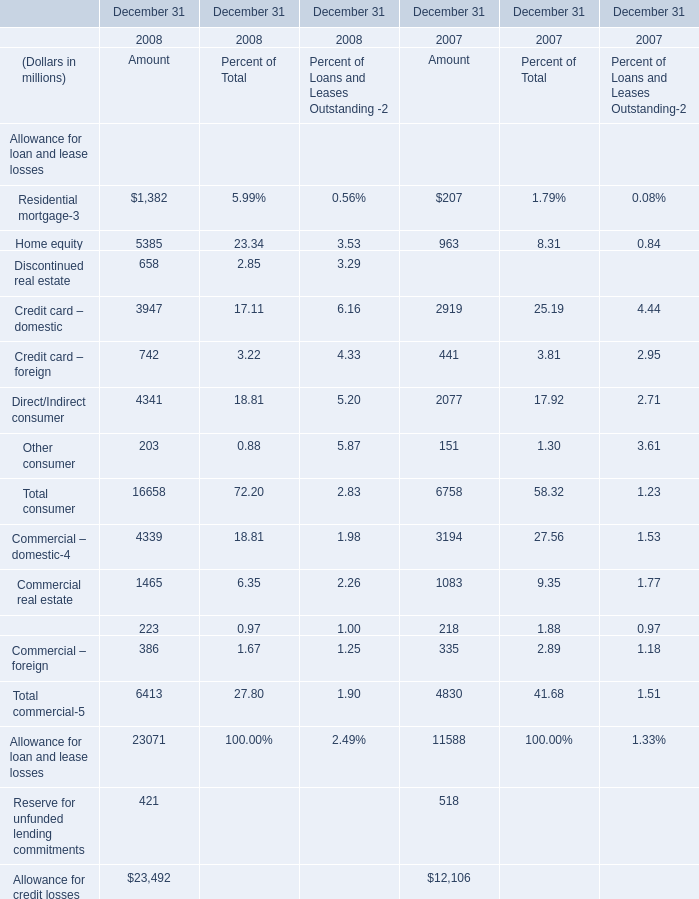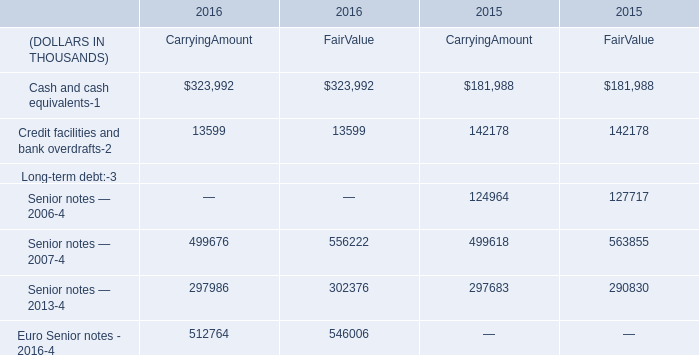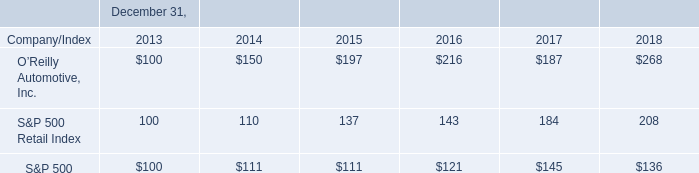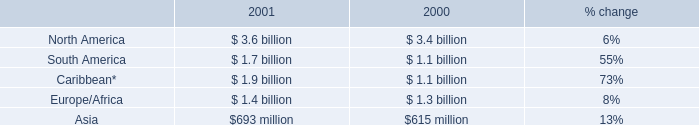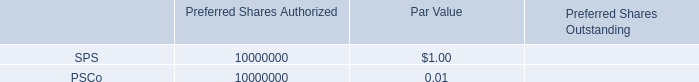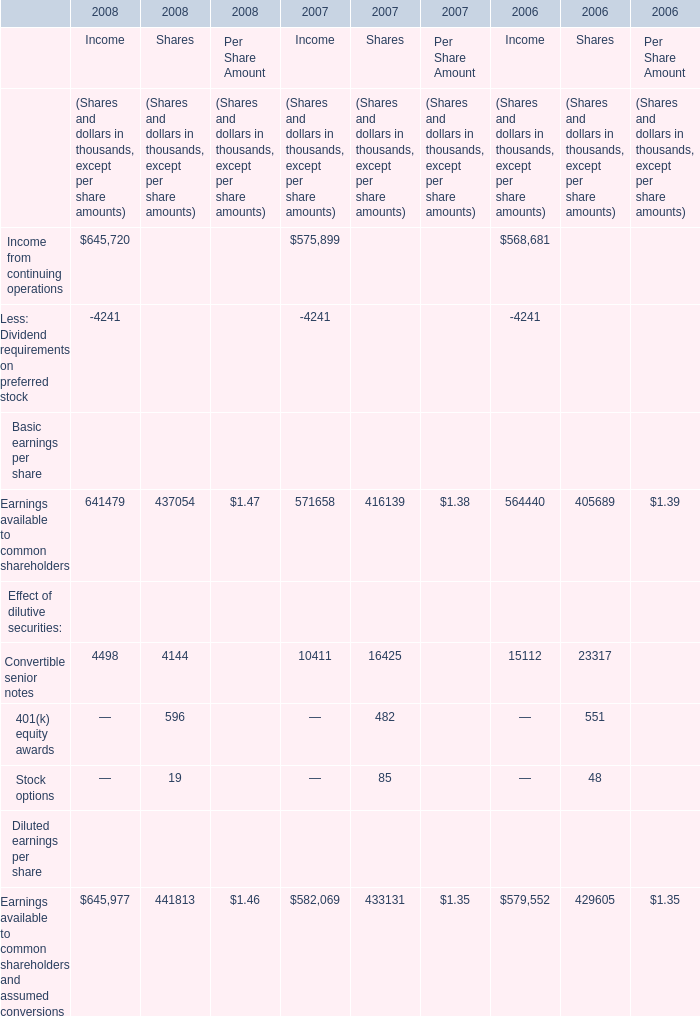What's the average of Commercial – domestic of December 31 2007 Amount, and Cash and cash equivalents of 2015 CarryingAmount ? 
Computations: ((3194.0 + 181988.0) / 2)
Answer: 92591.0. 